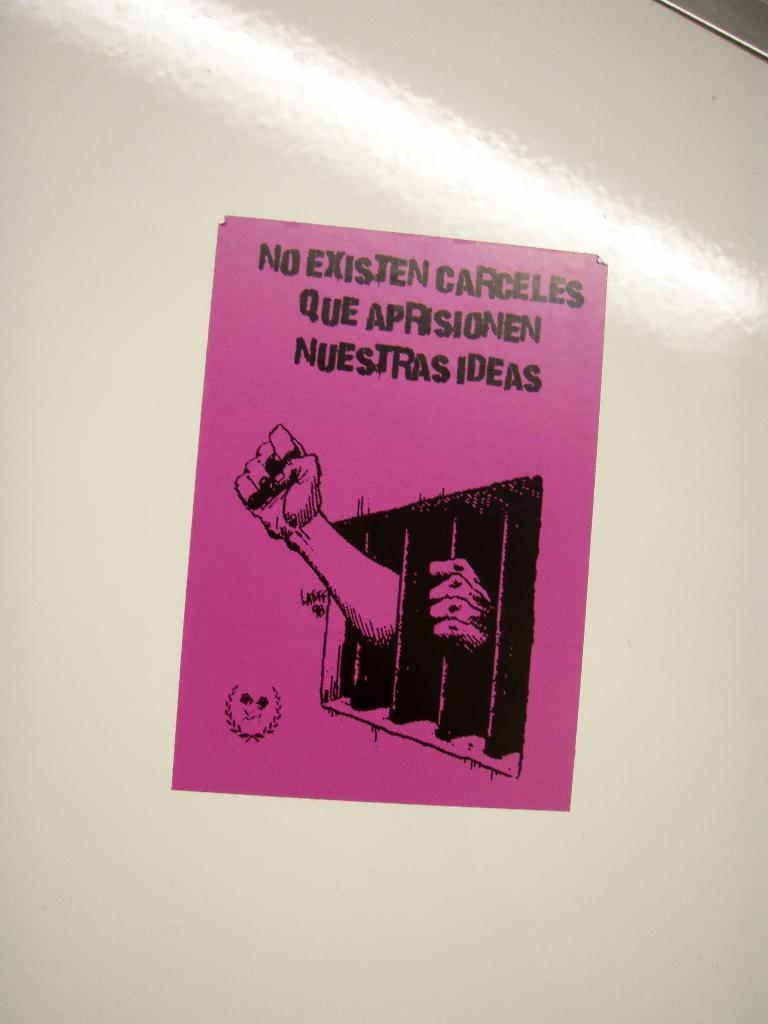<image>
Summarize the visual content of the image. A violet stamp that shows a person hands outside of a a jail cell and the words No Existen Carcelles Que Apprisionen Nuestras Dias\ 